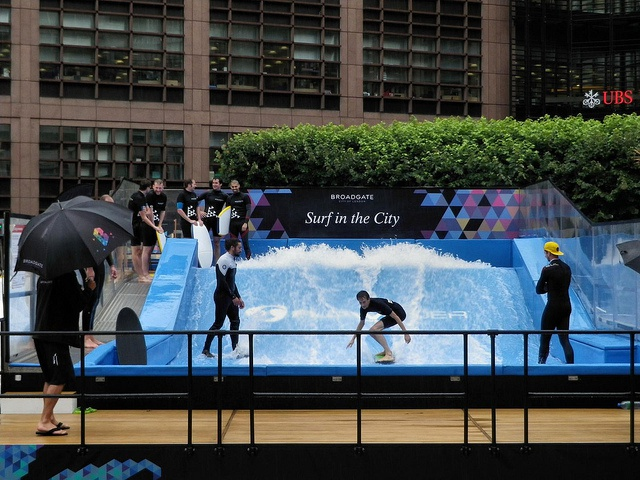Describe the objects in this image and their specific colors. I can see people in black, gray, and maroon tones, umbrella in black and gray tones, people in black, navy, gray, and olive tones, people in black, gray, darkgray, and navy tones, and people in black, gray, darkgray, and lightblue tones in this image. 